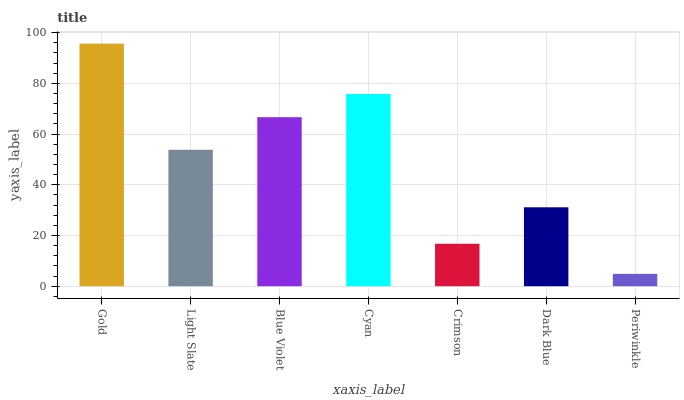Is Periwinkle the minimum?
Answer yes or no. Yes. Is Gold the maximum?
Answer yes or no. Yes. Is Light Slate the minimum?
Answer yes or no. No. Is Light Slate the maximum?
Answer yes or no. No. Is Gold greater than Light Slate?
Answer yes or no. Yes. Is Light Slate less than Gold?
Answer yes or no. Yes. Is Light Slate greater than Gold?
Answer yes or no. No. Is Gold less than Light Slate?
Answer yes or no. No. Is Light Slate the high median?
Answer yes or no. Yes. Is Light Slate the low median?
Answer yes or no. Yes. Is Dark Blue the high median?
Answer yes or no. No. Is Periwinkle the low median?
Answer yes or no. No. 